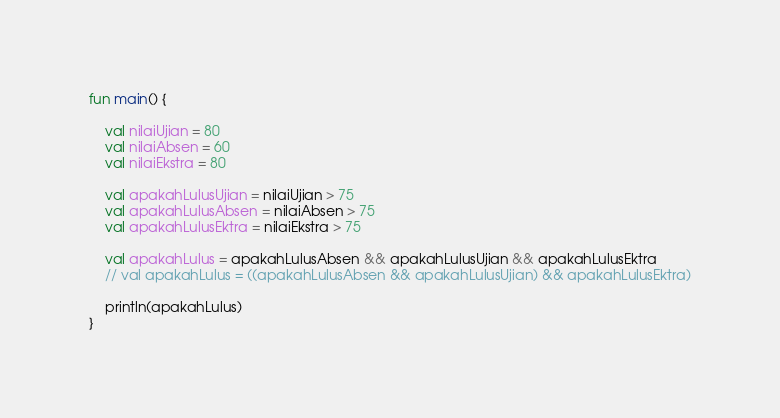Convert code to text. <code><loc_0><loc_0><loc_500><loc_500><_Kotlin_>fun main() {

    val nilaiUjian = 80
    val nilaiAbsen = 60
    val nilaiEkstra = 80

    val apakahLulusUjian = nilaiUjian > 75
    val apakahLulusAbsen = nilaiAbsen > 75
    val apakahLulusEktra = nilaiEkstra > 75

    val apakahLulus = apakahLulusAbsen && apakahLulusUjian && apakahLulusEktra
    // val apakahLulus = ((apakahLulusAbsen && apakahLulusUjian) && apakahLulusEktra)

    println(apakahLulus)
}</code> 